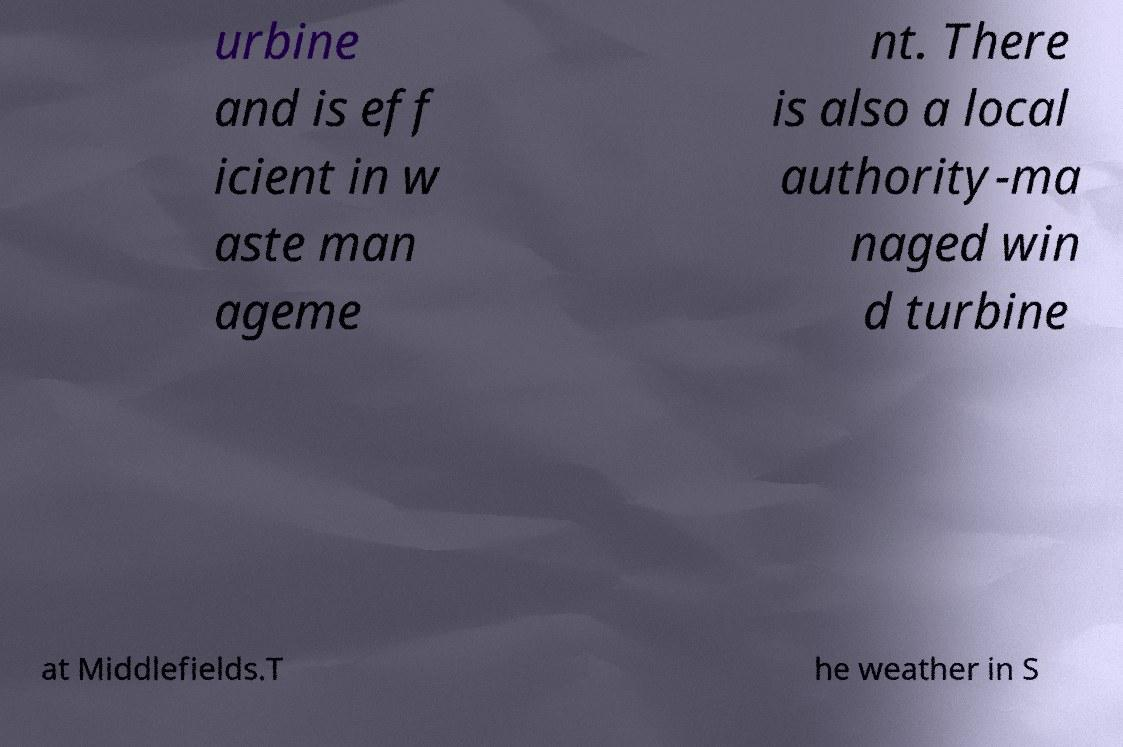For documentation purposes, I need the text within this image transcribed. Could you provide that? urbine and is eff icient in w aste man ageme nt. There is also a local authority-ma naged win d turbine at Middlefields.T he weather in S 